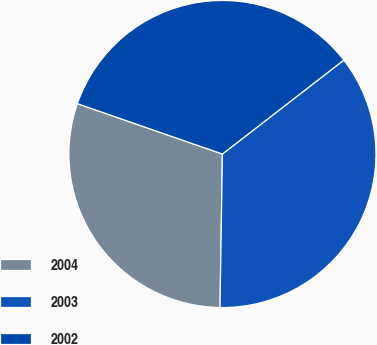Convert chart to OTSL. <chart><loc_0><loc_0><loc_500><loc_500><pie_chart><fcel>2004<fcel>2003<fcel>2002<nl><fcel>30.07%<fcel>35.73%<fcel>34.2%<nl></chart> 